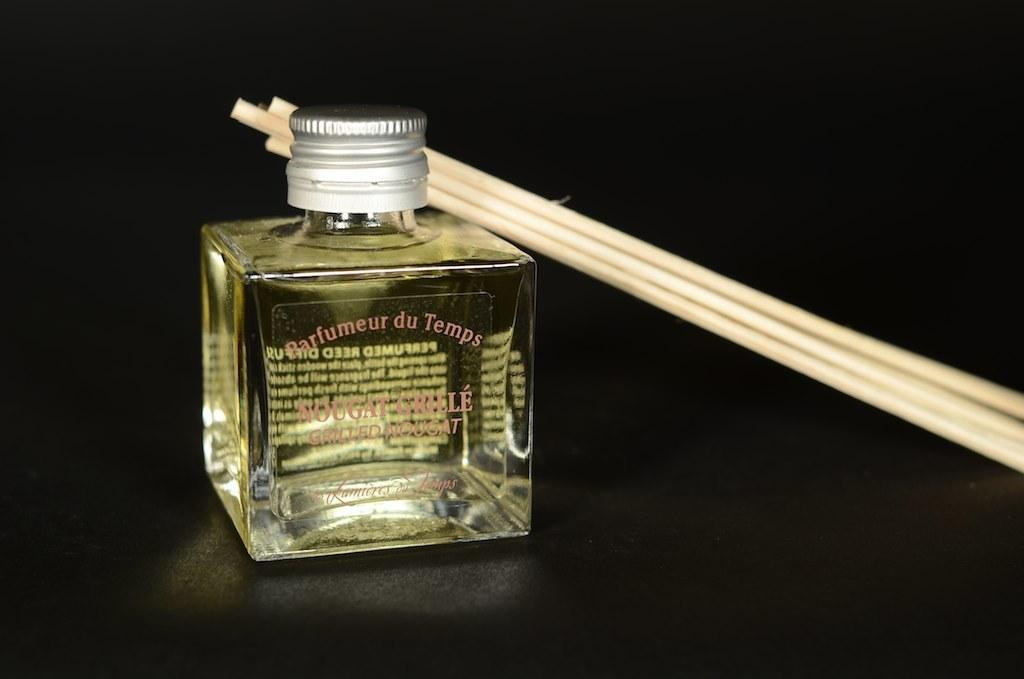What object can be seen in the image? There is a bottle in the image. What is attached to the bottle? There are sticks on the bottle. What can be observed about the background of the image? The background of the image is dark. How much income does the writer earn in the image? There is no writer or mention of income in the image; it only features a bottle with sticks on it. 